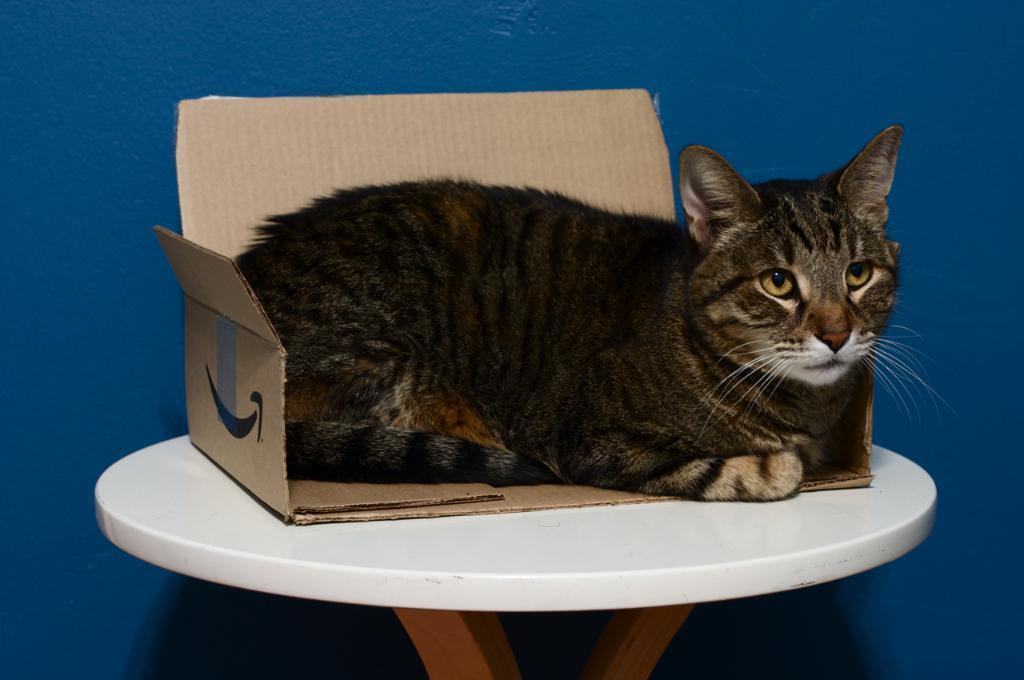Could you give a brief overview of what you see in this image? In this image i can see a cat is sitting on a table. 